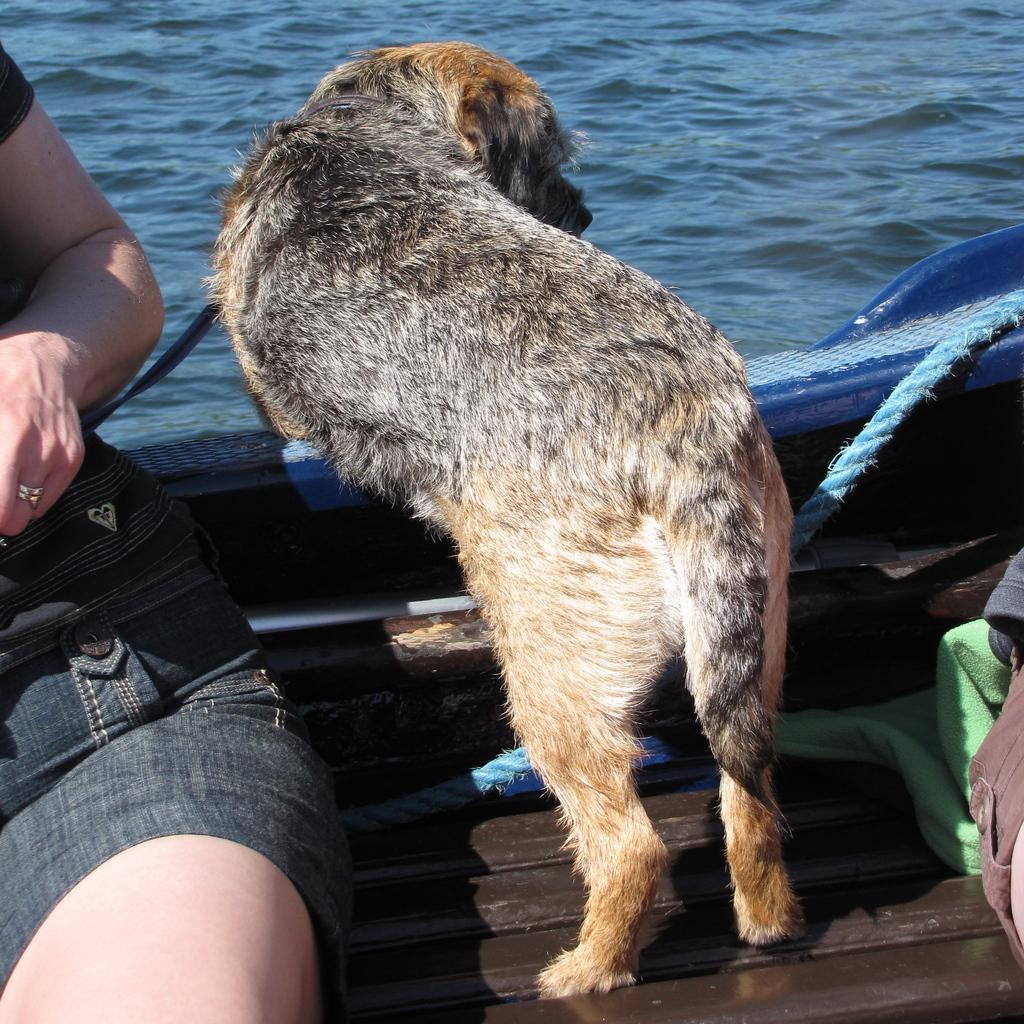Describe this image in one or two sentences. The picture might be taken in a boat. On the left we can see a person. In the center there is a dog. On the right there are rope, cloth, stick and other objects. At the top there is water. 